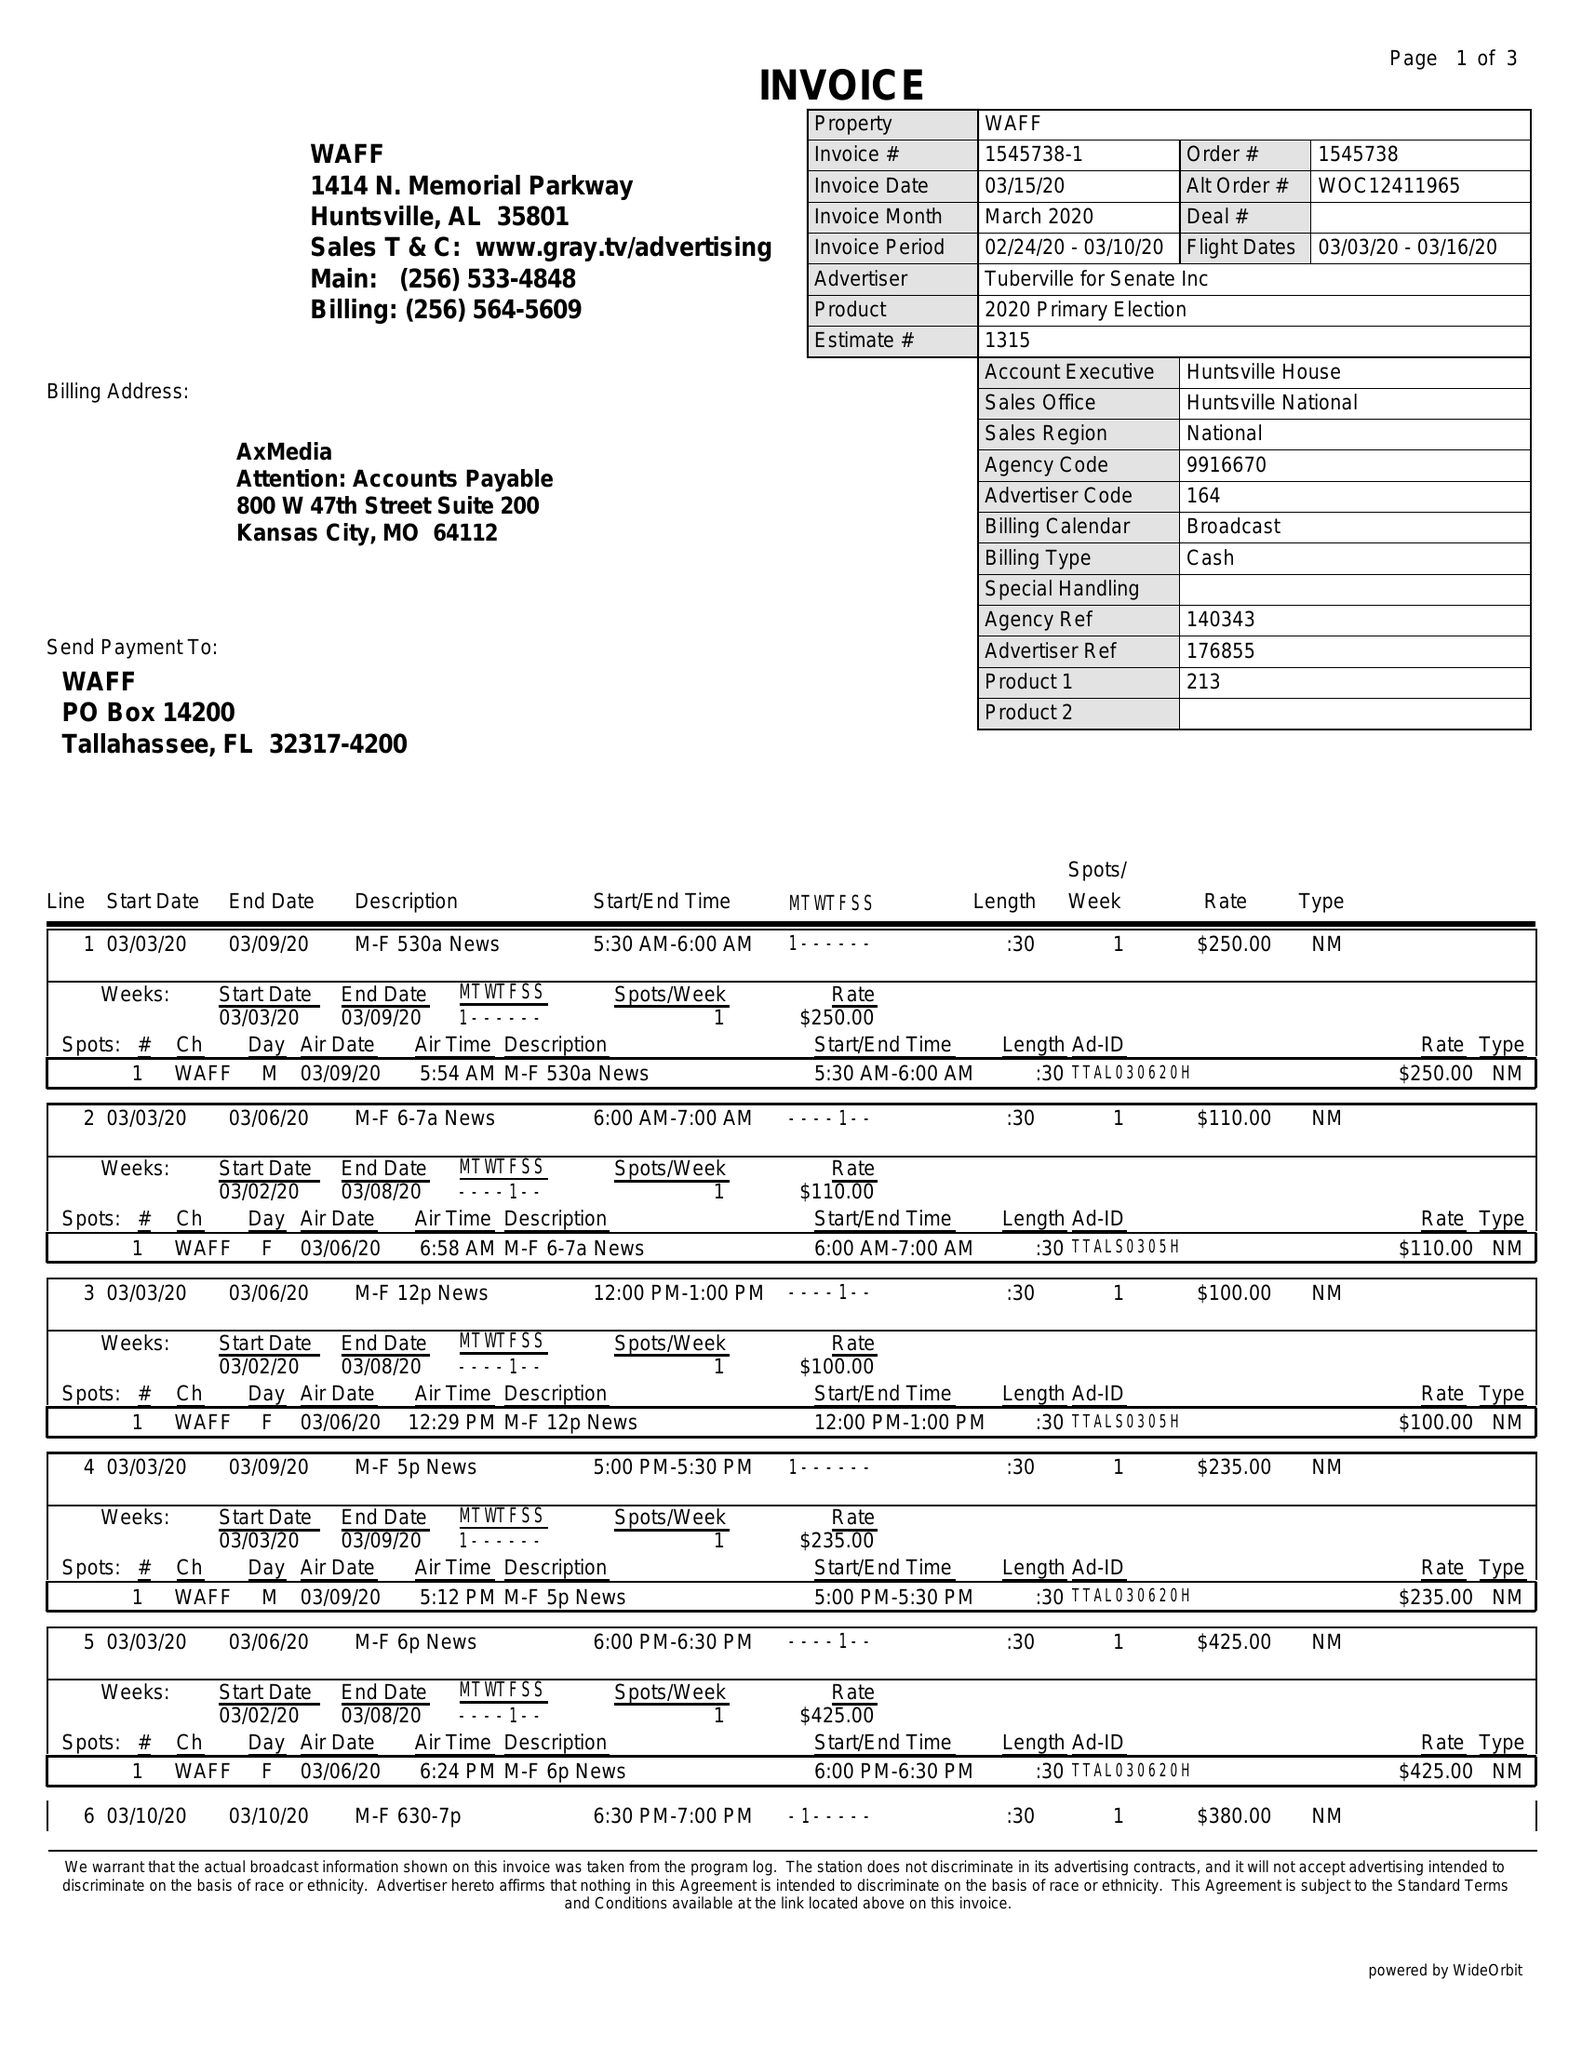What is the value for the flight_from?
Answer the question using a single word or phrase. 03/03/20 